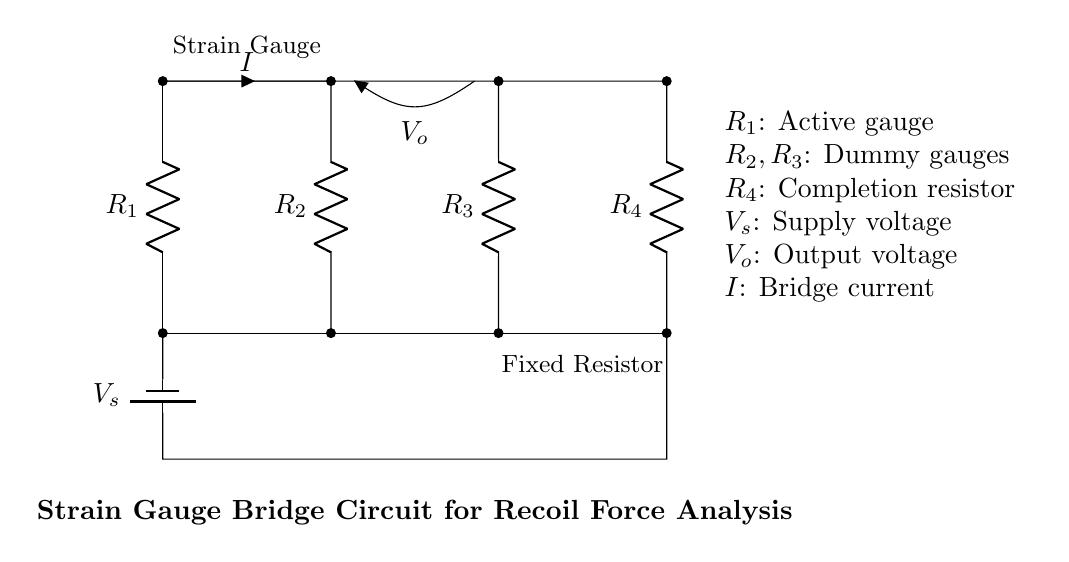What is the total number of resistors in this circuit? There are four resistors labeled as R1, R2, R3, and R4 in the circuit diagram.
Answer: Four What does R1 represent in the circuit? R1 is labeled as the active gauge in the diagram, indicating it is the main strain gauge for measurement.
Answer: Active gauge What is the purpose of R2 and R3? R2 and R3 are labeled as dummy gauges, which help balance the bridge and negate temperature effects in the measurement.
Answer: Dummy gauges What component provides the supply voltage? The supply voltage is provided by the component labeled as battery1 in the circuit.
Answer: Battery If the strain gauge in R1 experiences strain, how does it affect the output voltage? Strain in R1 alters its resistance, causing a change in the bridge balance, which results in a measurable output voltage, V_o.
Answer: Changes output voltage What is the type of circuit represented by this diagram? The diagram represents a strain gauge bridge circuit, commonly used for precise measurements of force or pressure.
Answer: Strain gauge bridge What does V_o signify in this circuit? V_o refers to the output voltage, which is measured across the middle of the bridge and varies based on the input from the strain gauge.
Answer: Output voltage 